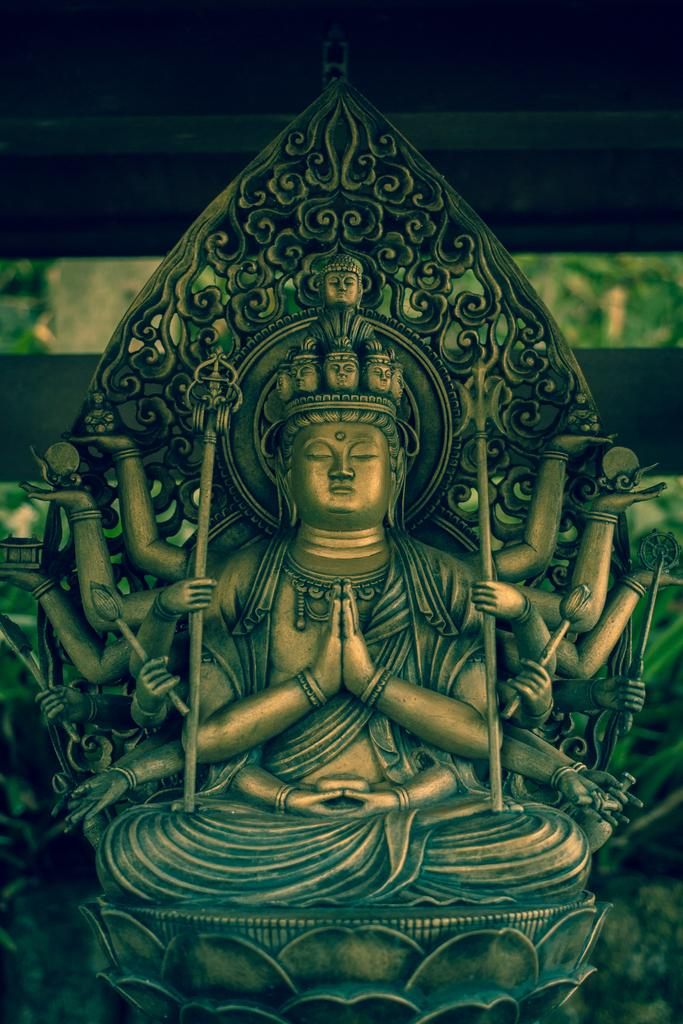What is the main subject in the image? There is a statue in the image. What can be seen in the background of the image? The background of the image is black. Is there any blood visible on the statue in the image? No, there is no blood visible on the statue in the image. Can you see any snails or sheep in the image? No, there are no snails or sheep present in the image. 